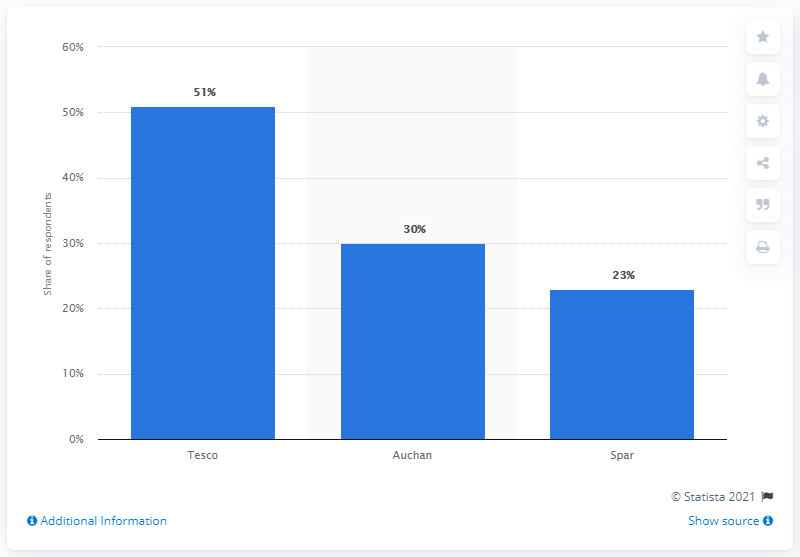Indicate a few pertinent items in this graphic. According to the survey, Tesco was the most preferred online grocery store among Hungarians who plan to make purchases in the next month. 